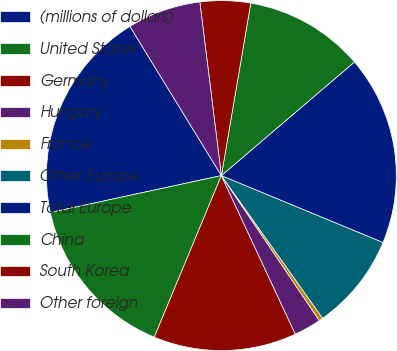<chart> <loc_0><loc_0><loc_500><loc_500><pie_chart><fcel>(millions of dollars)<fcel>United States<fcel>Germany<fcel>Hungary<fcel>France<fcel>Other Europe<fcel>Total Europe<fcel>China<fcel>South Korea<fcel>Other foreign<nl><fcel>19.63%<fcel>15.35%<fcel>13.21%<fcel>2.51%<fcel>0.37%<fcel>8.93%<fcel>17.49%<fcel>11.07%<fcel>4.65%<fcel>6.79%<nl></chart> 